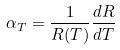<formula> <loc_0><loc_0><loc_500><loc_500>\alpha _ { T } = \frac { 1 } { R ( T ) } \frac { d R } { d T }</formula> 